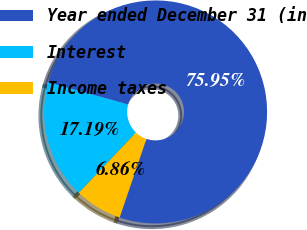<chart> <loc_0><loc_0><loc_500><loc_500><pie_chart><fcel>Year ended December 31 (in<fcel>Interest<fcel>Income taxes<nl><fcel>75.95%<fcel>17.19%<fcel>6.86%<nl></chart> 